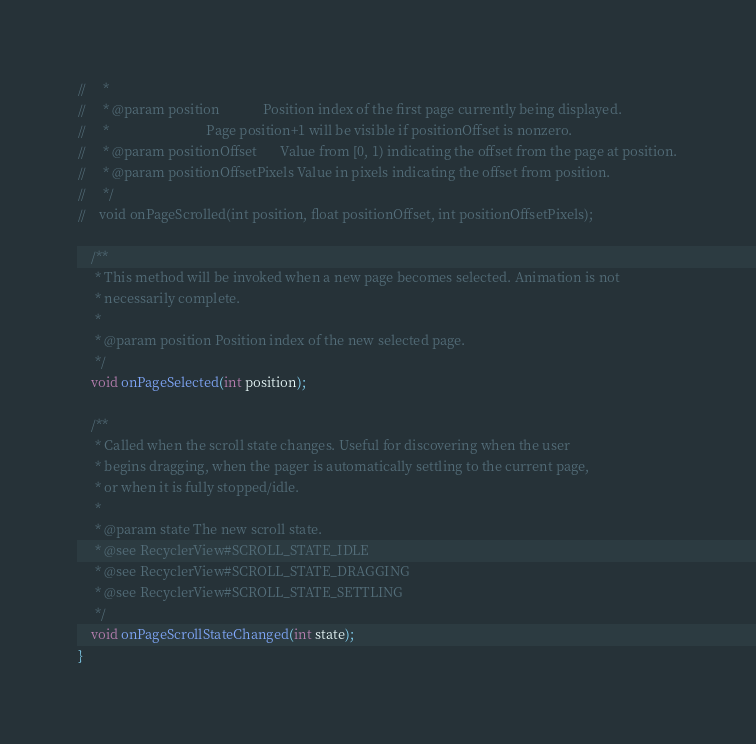<code> <loc_0><loc_0><loc_500><loc_500><_Java_>//     *
//     * @param position             Position index of the first page currently being displayed.
//     *                             Page position+1 will be visible if positionOffset is nonzero.
//     * @param positionOffset       Value from [0, 1) indicating the offset from the page at position.
//     * @param positionOffsetPixels Value in pixels indicating the offset from position.
//     */
//    void onPageScrolled(int position, float positionOffset, int positionOffsetPixels);

    /**
     * This method will be invoked when a new page becomes selected. Animation is not
     * necessarily complete.
     *
     * @param position Position index of the new selected page.
     */
    void onPageSelected(int position);

    /**
     * Called when the scroll state changes. Useful for discovering when the user
     * begins dragging, when the pager is automatically settling to the current page,
     * or when it is fully stopped/idle.
     *
     * @param state The new scroll state.
     * @see RecyclerView#SCROLL_STATE_IDLE
     * @see RecyclerView#SCROLL_STATE_DRAGGING
     * @see RecyclerView#SCROLL_STATE_SETTLING
     */
    void onPageScrollStateChanged(int state);
}
</code> 